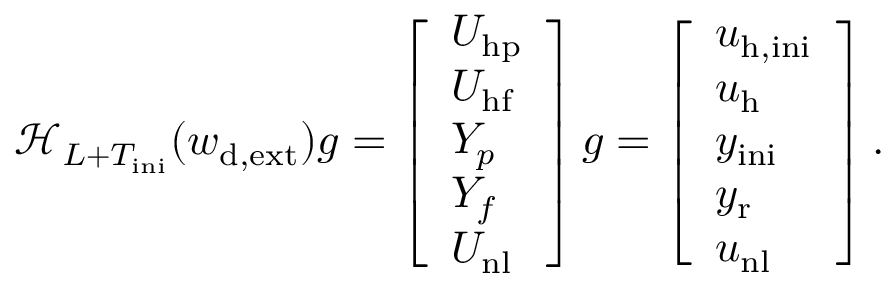<formula> <loc_0><loc_0><loc_500><loc_500>\mathcal { H } _ { L + T _ { i n i } } ( w _ { d , e x t } ) g = \left [ \begin{array} { l } { U _ { h p } } \\ { U _ { h f } } \\ { Y _ { p } } \\ { Y _ { f } } \\ { U _ { n l } } \end{array} \right ] g = \left [ \begin{array} { l } { u _ { h , i n i } } \\ { u _ { h } } \\ { y _ { i n i } } \\ { y _ { r } } \\ { u _ { n l } } \end{array} \right ] .</formula> 